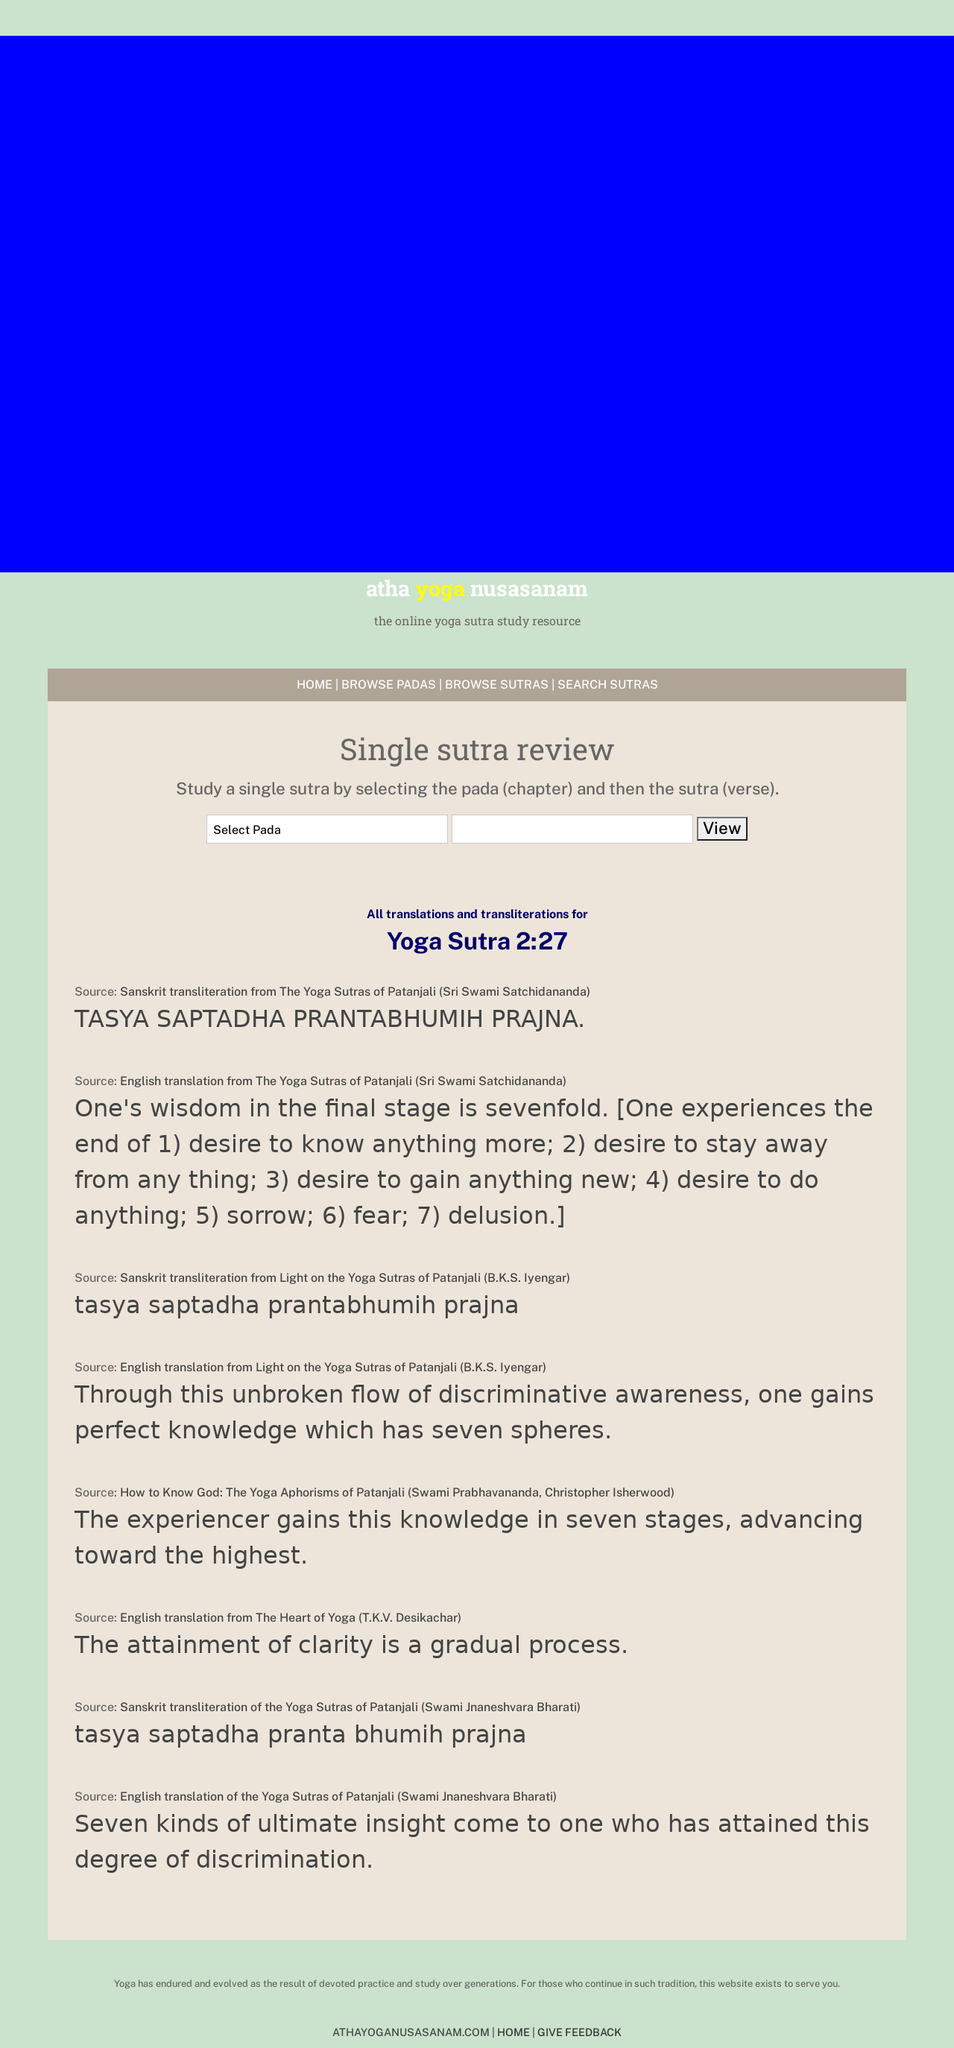Can you describe the elements visible in the interface of this yoga sutra study resource screenshot? The image shows a webpage of a yoga sutra study resource named 'atha yoga nusasanam.' The top section of the page has a navigation menu with links such as 'HOME', 'BROWSE PADAS', 'BROWSE SUTRAS', and 'SEARCH SUTRAS'. Below this is a major section titled 'Single sutra review' where users can select a 'Pada' (chapter) and then view specific 'Sutra' (verse) details. The content provides various translations and transliterations of 'Yoga Sutra 2:27' from different sources, reflecting various interpretations of the text. 